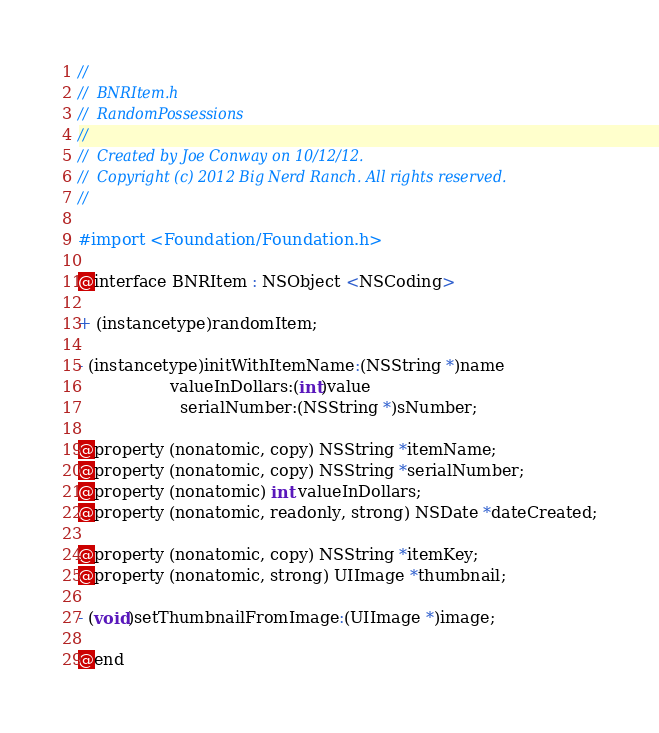<code> <loc_0><loc_0><loc_500><loc_500><_C_>//
//  BNRItem.h
//  RandomPossessions
//
//  Created by Joe Conway on 10/12/12.
//  Copyright (c) 2012 Big Nerd Ranch. All rights reserved.
//

#import <Foundation/Foundation.h>

@interface BNRItem : NSObject <NSCoding>

+ (instancetype)randomItem;

- (instancetype)initWithItemName:(NSString *)name
                  valueInDollars:(int)value
                    serialNumber:(NSString *)sNumber;
 
@property (nonatomic, copy) NSString *itemName;
@property (nonatomic, copy) NSString *serialNumber;
@property (nonatomic) int valueInDollars;
@property (nonatomic, readonly, strong) NSDate *dateCreated;

@property (nonatomic, copy) NSString *itemKey;
@property (nonatomic, strong) UIImage *thumbnail;

- (void)setThumbnailFromImage:(UIImage *)image;

@end
</code> 